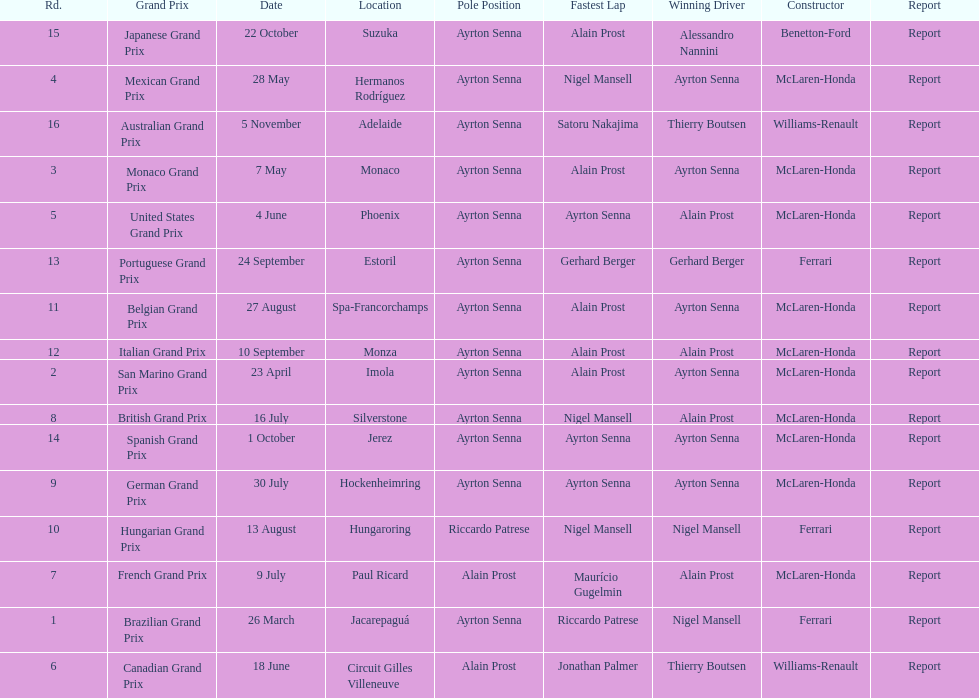Who had the fastest lap at the german grand prix? Ayrton Senna. Write the full table. {'header': ['Rd.', 'Grand Prix', 'Date', 'Location', 'Pole Position', 'Fastest Lap', 'Winning Driver', 'Constructor', 'Report'], 'rows': [['15', 'Japanese Grand Prix', '22 October', 'Suzuka', 'Ayrton Senna', 'Alain Prost', 'Alessandro Nannini', 'Benetton-Ford', 'Report'], ['4', 'Mexican Grand Prix', '28 May', 'Hermanos Rodríguez', 'Ayrton Senna', 'Nigel Mansell', 'Ayrton Senna', 'McLaren-Honda', 'Report'], ['16', 'Australian Grand Prix', '5 November', 'Adelaide', 'Ayrton Senna', 'Satoru Nakajima', 'Thierry Boutsen', 'Williams-Renault', 'Report'], ['3', 'Monaco Grand Prix', '7 May', 'Monaco', 'Ayrton Senna', 'Alain Prost', 'Ayrton Senna', 'McLaren-Honda', 'Report'], ['5', 'United States Grand Prix', '4 June', 'Phoenix', 'Ayrton Senna', 'Ayrton Senna', 'Alain Prost', 'McLaren-Honda', 'Report'], ['13', 'Portuguese Grand Prix', '24 September', 'Estoril', 'Ayrton Senna', 'Gerhard Berger', 'Gerhard Berger', 'Ferrari', 'Report'], ['11', 'Belgian Grand Prix', '27 August', 'Spa-Francorchamps', 'Ayrton Senna', 'Alain Prost', 'Ayrton Senna', 'McLaren-Honda', 'Report'], ['12', 'Italian Grand Prix', '10 September', 'Monza', 'Ayrton Senna', 'Alain Prost', 'Alain Prost', 'McLaren-Honda', 'Report'], ['2', 'San Marino Grand Prix', '23 April', 'Imola', 'Ayrton Senna', 'Alain Prost', 'Ayrton Senna', 'McLaren-Honda', 'Report'], ['8', 'British Grand Prix', '16 July', 'Silverstone', 'Ayrton Senna', 'Nigel Mansell', 'Alain Prost', 'McLaren-Honda', 'Report'], ['14', 'Spanish Grand Prix', '1 October', 'Jerez', 'Ayrton Senna', 'Ayrton Senna', 'Ayrton Senna', 'McLaren-Honda', 'Report'], ['9', 'German Grand Prix', '30 July', 'Hockenheimring', 'Ayrton Senna', 'Ayrton Senna', 'Ayrton Senna', 'McLaren-Honda', 'Report'], ['10', 'Hungarian Grand Prix', '13 August', 'Hungaroring', 'Riccardo Patrese', 'Nigel Mansell', 'Nigel Mansell', 'Ferrari', 'Report'], ['7', 'French Grand Prix', '9 July', 'Paul Ricard', 'Alain Prost', 'Maurício Gugelmin', 'Alain Prost', 'McLaren-Honda', 'Report'], ['1', 'Brazilian Grand Prix', '26 March', 'Jacarepaguá', 'Ayrton Senna', 'Riccardo Patrese', 'Nigel Mansell', 'Ferrari', 'Report'], ['6', 'Canadian Grand Prix', '18 June', 'Circuit Gilles Villeneuve', 'Alain Prost', 'Jonathan Palmer', 'Thierry Boutsen', 'Williams-Renault', 'Report']]} 